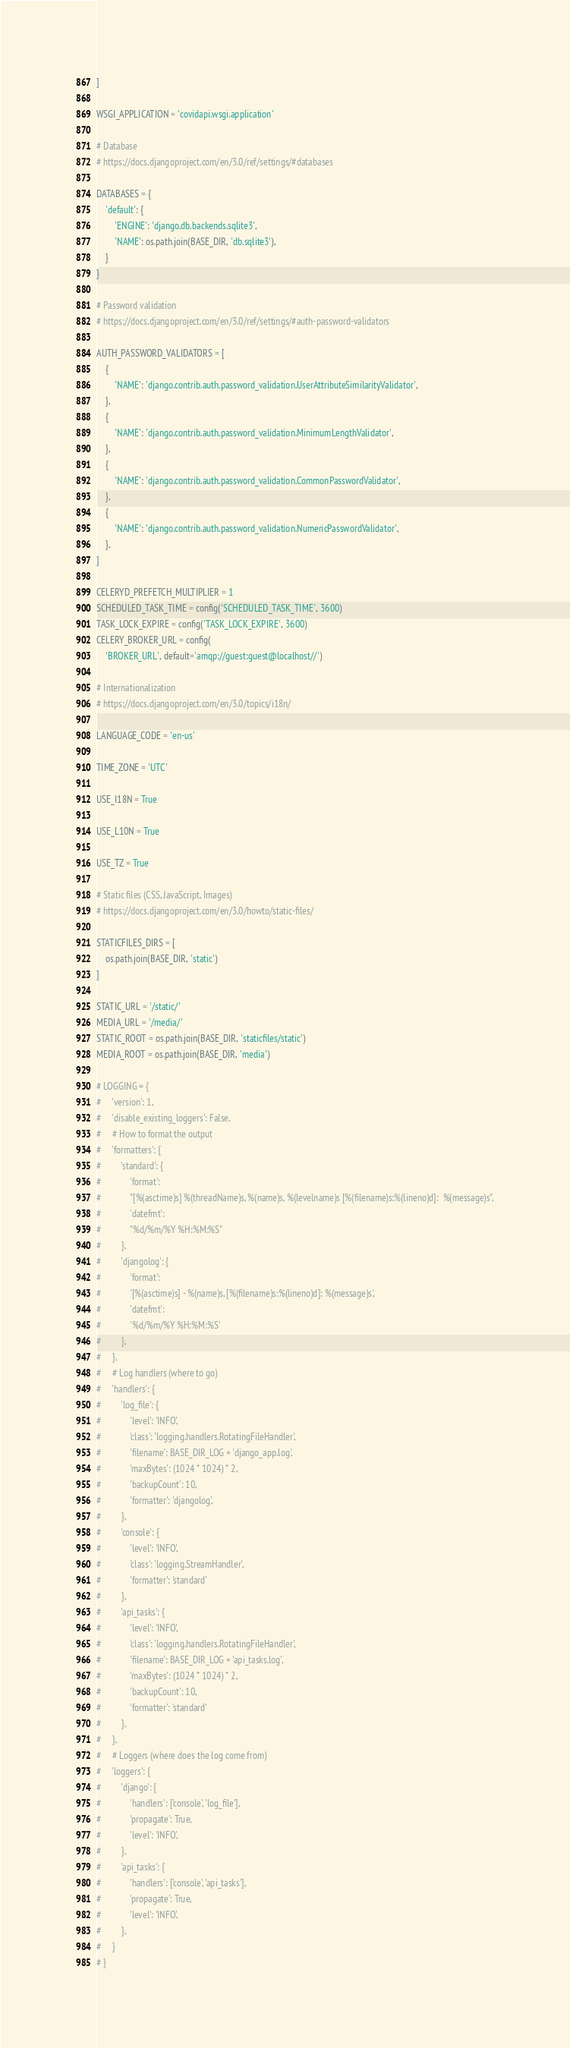<code> <loc_0><loc_0><loc_500><loc_500><_Python_>]

WSGI_APPLICATION = 'covidapi.wsgi.application'

# Database
# https://docs.djangoproject.com/en/3.0/ref/settings/#databases

DATABASES = {
    'default': {
        'ENGINE': 'django.db.backends.sqlite3',
        'NAME': os.path.join(BASE_DIR, 'db.sqlite3'),
    }
}

# Password validation
# https://docs.djangoproject.com/en/3.0/ref/settings/#auth-password-validators

AUTH_PASSWORD_VALIDATORS = [
    {
        'NAME': 'django.contrib.auth.password_validation.UserAttributeSimilarityValidator',
    },
    {
        'NAME': 'django.contrib.auth.password_validation.MinimumLengthValidator',
    },
    {
        'NAME': 'django.contrib.auth.password_validation.CommonPasswordValidator',
    },
    {
        'NAME': 'django.contrib.auth.password_validation.NumericPasswordValidator',
    },
]

CELERYD_PREFETCH_MULTIPLIER = 1
SCHEDULED_TASK_TIME = config('SCHEDULED_TASK_TIME', 3600)
TASK_LOCK_EXPIRE = config('TASK_LOCK_EXPIRE', 3600)
CELERY_BROKER_URL = config(
    'BROKER_URL', default='amqp://guest:guest@localhost//')

# Internationalization
# https://docs.djangoproject.com/en/3.0/topics/i18n/

LANGUAGE_CODE = 'en-us'

TIME_ZONE = 'UTC'

USE_I18N = True

USE_L10N = True

USE_TZ = True

# Static files (CSS, JavaScript, Images)
# https://docs.djangoproject.com/en/3.0/howto/static-files/

STATICFILES_DIRS = [
    os.path.join(BASE_DIR, 'static')
]

STATIC_URL = '/static/'
MEDIA_URL = '/media/'
STATIC_ROOT = os.path.join(BASE_DIR, 'staticfiles/static')
MEDIA_ROOT = os.path.join(BASE_DIR, 'media')

# LOGGING = {
#     'version': 1,
#     'disable_existing_loggers': False,
#     # How to format the output
#     'formatters': {
#         'standard': {
#             'format':
#             "[%(asctime)s] %(threadName)s, %(name)s, %(levelname)s [%(filename)s:%(lineno)d]:  %(message)s",
#             'datefmt':
#             "%d/%m/%Y %H:%M:%S"
#         },
#         'djangolog': {
#             'format':
#             '[%(asctime)s] - %(name)s, [%(filename)s:%(lineno)d]: %(message)s',
#             'datefmt':
#             '%d/%m/%Y %H:%M:%S'
#         },
#     },
#     # Log handlers (where to go)
#     'handlers': {
#         'log_file': {
#             'level': 'INFO',
#             'class': 'logging.handlers.RotatingFileHandler',
#             'filename': BASE_DIR_LOG + 'django_app.log',
#             'maxBytes': (1024 * 1024) * 2,
#             'backupCount': 10,
#             'formatter': 'djangolog',
#         },
#         'console': {
#             'level': 'INFO',
#             'class': 'logging.StreamHandler',
#             'formatter': 'standard'
#         },
#         'api_tasks': {
#             'level': 'INFO',
#             'class': 'logging.handlers.RotatingFileHandler',
#             'filename': BASE_DIR_LOG + 'api_tasks.log',
#             'maxBytes': (1024 * 1024) * 2,
#             'backupCount': 10,
#             'formatter': 'standard'
#         },
#     },
#     # Loggers (where does the log come from)
#     'loggers': {
#         'django': {
#             'handlers': ['console', 'log_file'],
#             'propagate': True,
#             'level': 'INFO',
#         },
#         'api_tasks': {
#             'handlers': ['console', 'api_tasks'],
#             'propagate': True,
#             'level': 'INFO',
#         },
#     }
# }
</code> 